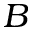<formula> <loc_0><loc_0><loc_500><loc_500>B</formula> 